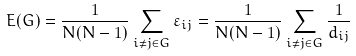Convert formula to latex. <formula><loc_0><loc_0><loc_500><loc_500>E ( G ) = \frac { 1 } { N ( N - 1 ) } \sum _ { i \neq { j } \in { G } } { { \varepsilon _ { i j } } } = \frac { 1 } { N ( N - 1 ) } \sum _ { i \neq { j } \in { G } } { \frac { 1 } { d _ { i j } } }</formula> 